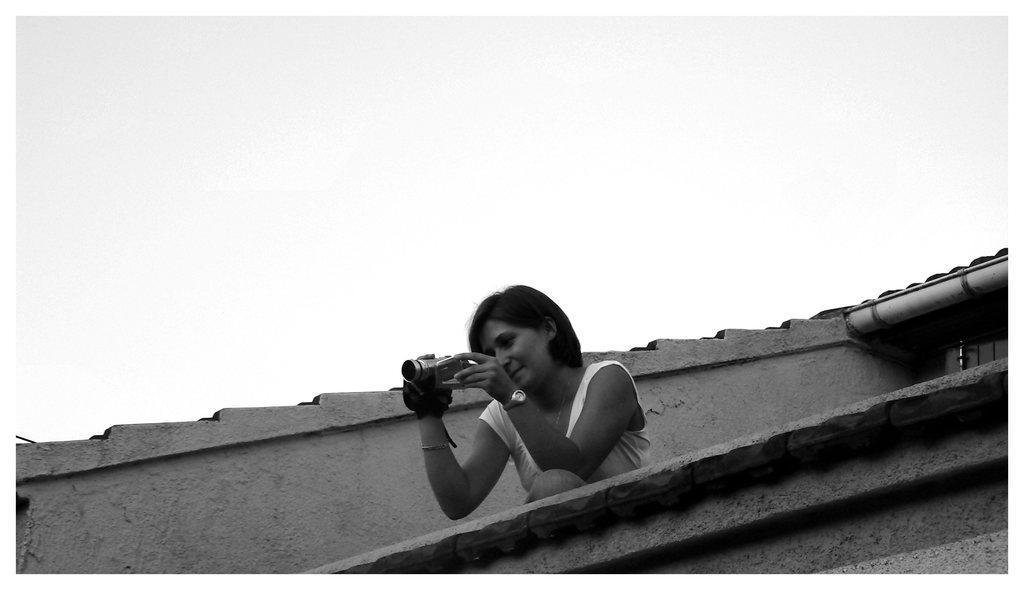Can you describe this image briefly? This image is taken outdoors. This image is a black and white image. At the top of the image there is the sky. At the bottom of the image there is a wall. In the middle of the image a woman is standing and she is clicking pictures with a camera. In the background there is a wall. 